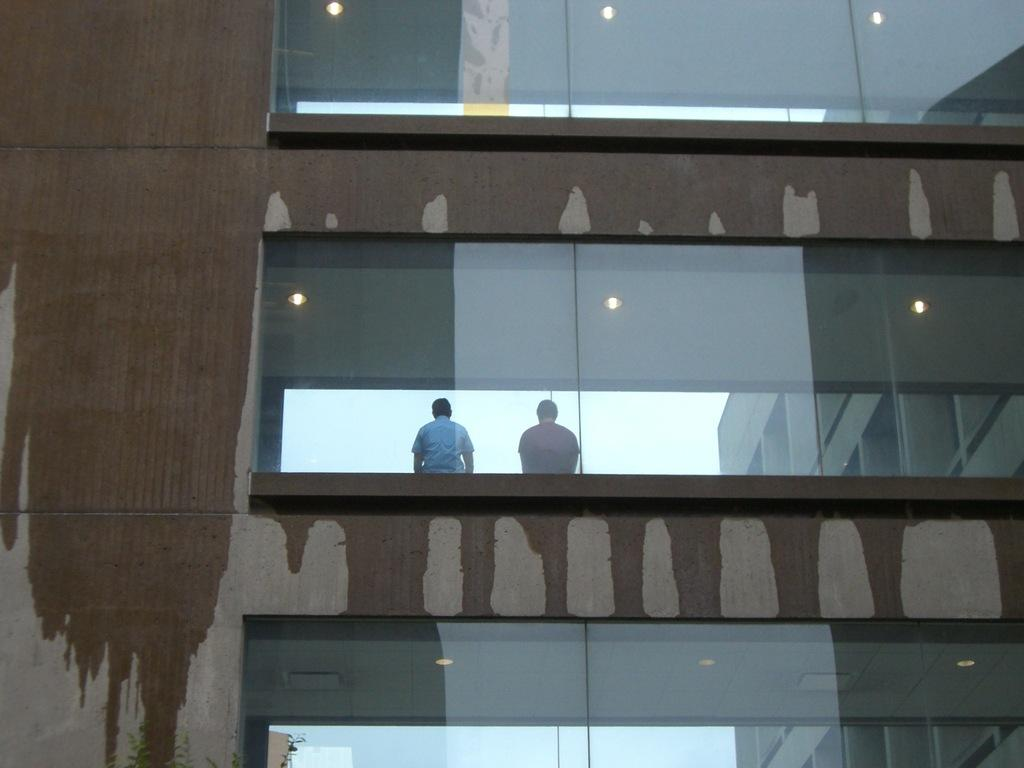What structure is visible in the image? There is a building in the image. Who or what can be seen in the middle of the image? There are two persons in the middle of the image. What feature of the building is mentioned at the top, bottom, and middle? There are lights at the top, bottom, and middle of the building. What type of produce is being harvested by the persons in the image? There is no produce or harvesting activity depicted in the image; it features a building with lights and two persons in the middle. How many mittens can be seen on the persons in the image? There is no mention of mittens or any clothing items in the image; it only shows a building and two persons. 